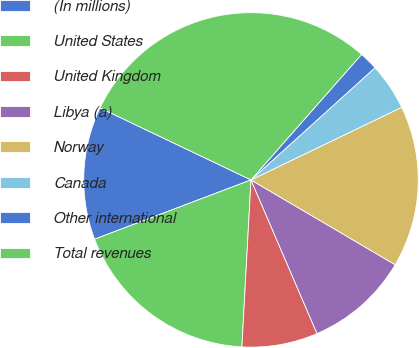Convert chart to OTSL. <chart><loc_0><loc_0><loc_500><loc_500><pie_chart><fcel>(In millions)<fcel>United States<fcel>United Kingdom<fcel>Libya (a)<fcel>Norway<fcel>Canada<fcel>Other international<fcel>Total revenues<nl><fcel>12.85%<fcel>18.37%<fcel>7.32%<fcel>10.08%<fcel>15.61%<fcel>4.56%<fcel>1.8%<fcel>29.41%<nl></chart> 